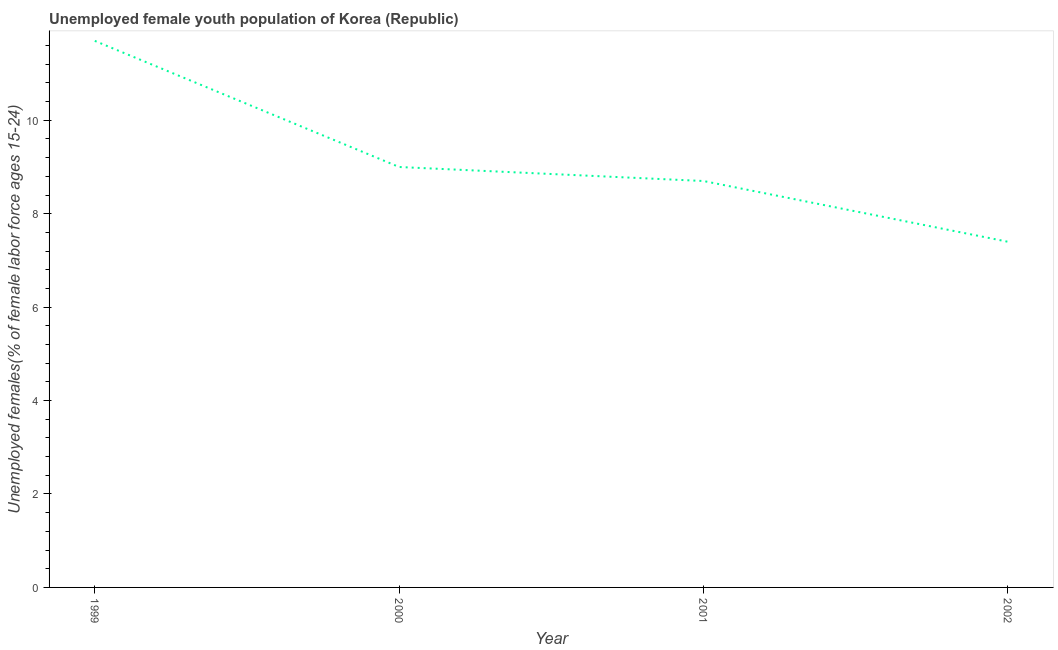What is the unemployed female youth in 1999?
Your answer should be very brief. 11.7. Across all years, what is the maximum unemployed female youth?
Your answer should be very brief. 11.7. Across all years, what is the minimum unemployed female youth?
Offer a very short reply. 7.4. In which year was the unemployed female youth maximum?
Provide a succinct answer. 1999. In which year was the unemployed female youth minimum?
Ensure brevity in your answer.  2002. What is the sum of the unemployed female youth?
Provide a short and direct response. 36.8. What is the difference between the unemployed female youth in 2000 and 2001?
Offer a very short reply. 0.3. What is the average unemployed female youth per year?
Ensure brevity in your answer.  9.2. What is the median unemployed female youth?
Your answer should be compact. 8.85. Do a majority of the years between 2000 and 2002 (inclusive) have unemployed female youth greater than 4.4 %?
Your answer should be compact. Yes. What is the ratio of the unemployed female youth in 1999 to that in 2002?
Your answer should be compact. 1.58. What is the difference between the highest and the second highest unemployed female youth?
Your answer should be very brief. 2.7. What is the difference between the highest and the lowest unemployed female youth?
Your answer should be very brief. 4.3. How many lines are there?
Offer a terse response. 1. Does the graph contain any zero values?
Your answer should be compact. No. Does the graph contain grids?
Ensure brevity in your answer.  No. What is the title of the graph?
Offer a very short reply. Unemployed female youth population of Korea (Republic). What is the label or title of the X-axis?
Make the answer very short. Year. What is the label or title of the Y-axis?
Offer a terse response. Unemployed females(% of female labor force ages 15-24). What is the Unemployed females(% of female labor force ages 15-24) in 1999?
Make the answer very short. 11.7. What is the Unemployed females(% of female labor force ages 15-24) of 2001?
Keep it short and to the point. 8.7. What is the Unemployed females(% of female labor force ages 15-24) in 2002?
Offer a terse response. 7.4. What is the difference between the Unemployed females(% of female labor force ages 15-24) in 1999 and 2002?
Ensure brevity in your answer.  4.3. What is the difference between the Unemployed females(% of female labor force ages 15-24) in 2001 and 2002?
Give a very brief answer. 1.3. What is the ratio of the Unemployed females(% of female labor force ages 15-24) in 1999 to that in 2001?
Your answer should be very brief. 1.34. What is the ratio of the Unemployed females(% of female labor force ages 15-24) in 1999 to that in 2002?
Offer a terse response. 1.58. What is the ratio of the Unemployed females(% of female labor force ages 15-24) in 2000 to that in 2001?
Keep it short and to the point. 1.03. What is the ratio of the Unemployed females(% of female labor force ages 15-24) in 2000 to that in 2002?
Your answer should be compact. 1.22. What is the ratio of the Unemployed females(% of female labor force ages 15-24) in 2001 to that in 2002?
Your answer should be compact. 1.18. 